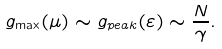<formula> <loc_0><loc_0><loc_500><loc_500>g _ { \max } ( \mu ) \sim g _ { p e a k } ( \varepsilon ) \sim \frac { N } { \gamma } .</formula> 